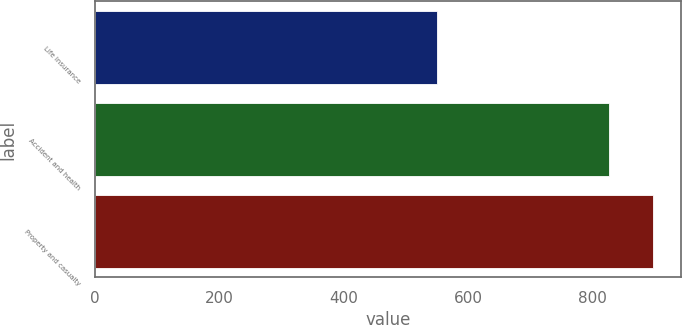Convert chart. <chart><loc_0><loc_0><loc_500><loc_500><bar_chart><fcel>Life insurance<fcel>Accident and health<fcel>Property and casualty<nl><fcel>550<fcel>827<fcel>897<nl></chart> 